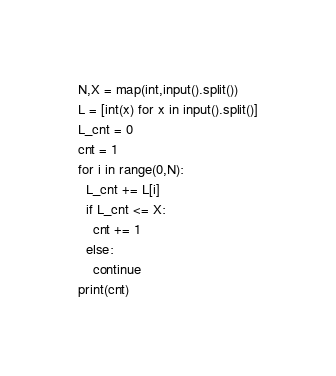Convert code to text. <code><loc_0><loc_0><loc_500><loc_500><_Python_>N,X = map(int,input().split())
L = [int(x) for x in input().split()]
L_cnt = 0
cnt = 1
for i in range(0,N):
  L_cnt += L[i]
  if L_cnt <= X:
    cnt += 1
  else:
    continue
print(cnt)</code> 